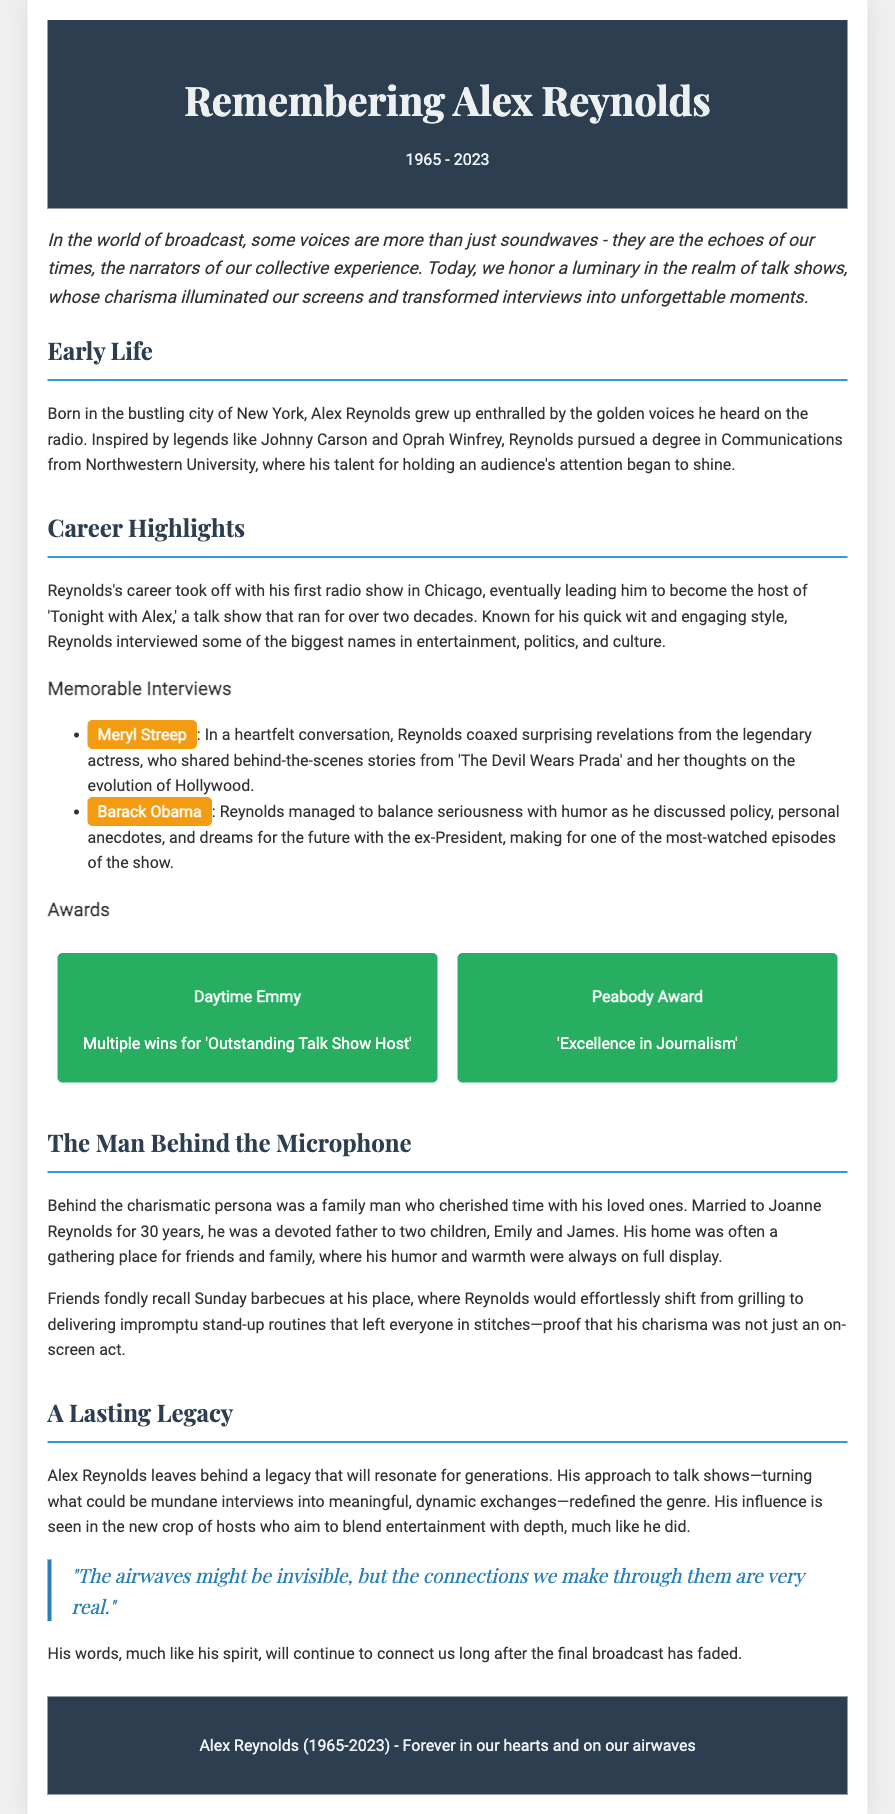What year was Alex Reynolds born? The document states that Alex Reynolds was born in the year 1965.
Answer: 1965 What television show did Alex Reynolds host? The obituary mentions that he was the host of 'Tonight with Alex.'
Answer: Tonight with Alex How many years did 'Tonight with Alex' run? The document indicates that the show ran for over two decades, which refers to approximately 20 years.
Answer: over two decades Which award did Alex Reynolds win multiple times? The document specifies that he won multiple Daytime Emmy Awards.
Answer: Daytime Emmy What was Alex Reynolds's alma mater? According to the obituary, Alex Reynolds pursued a degree in Communications from Northwestern University.
Answer: Northwestern University Who was Alex Reynolds married to? The document notes that he was married to Joanne Reynolds for 30 years.
Answer: Joanne Reynolds What quality did Reynolds value in his personal life? The document describes him as a devoted family man who cherished time with his loved ones.
Answer: Family man What did Alex Reynolds redefine in the talk show genre? The obituary states that he transformed mundane interviews into meaningful, dynamic exchanges.
Answer: interviews What was a highlight from Reynolds's interview with Barack Obama? The document highlights that Reynolds balanced seriousness with humor during their conversation.
Answer: balance of seriousness and humor 